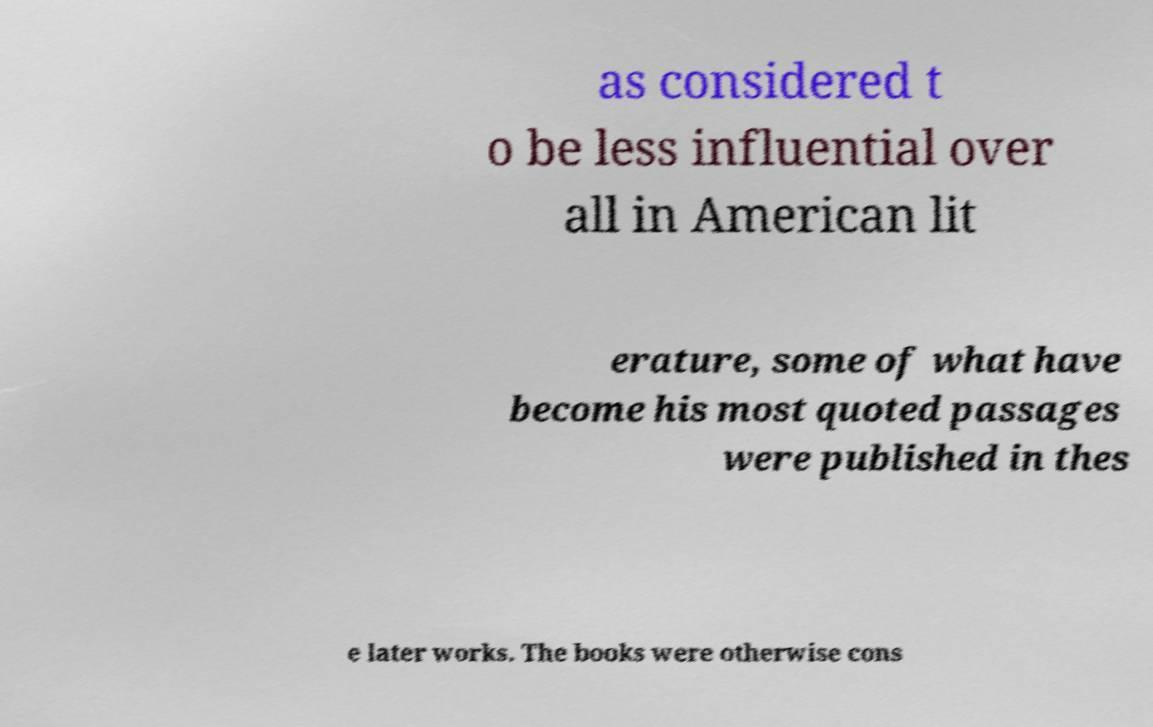Please identify and transcribe the text found in this image. as considered t o be less influential over all in American lit erature, some of what have become his most quoted passages were published in thes e later works. The books were otherwise cons 